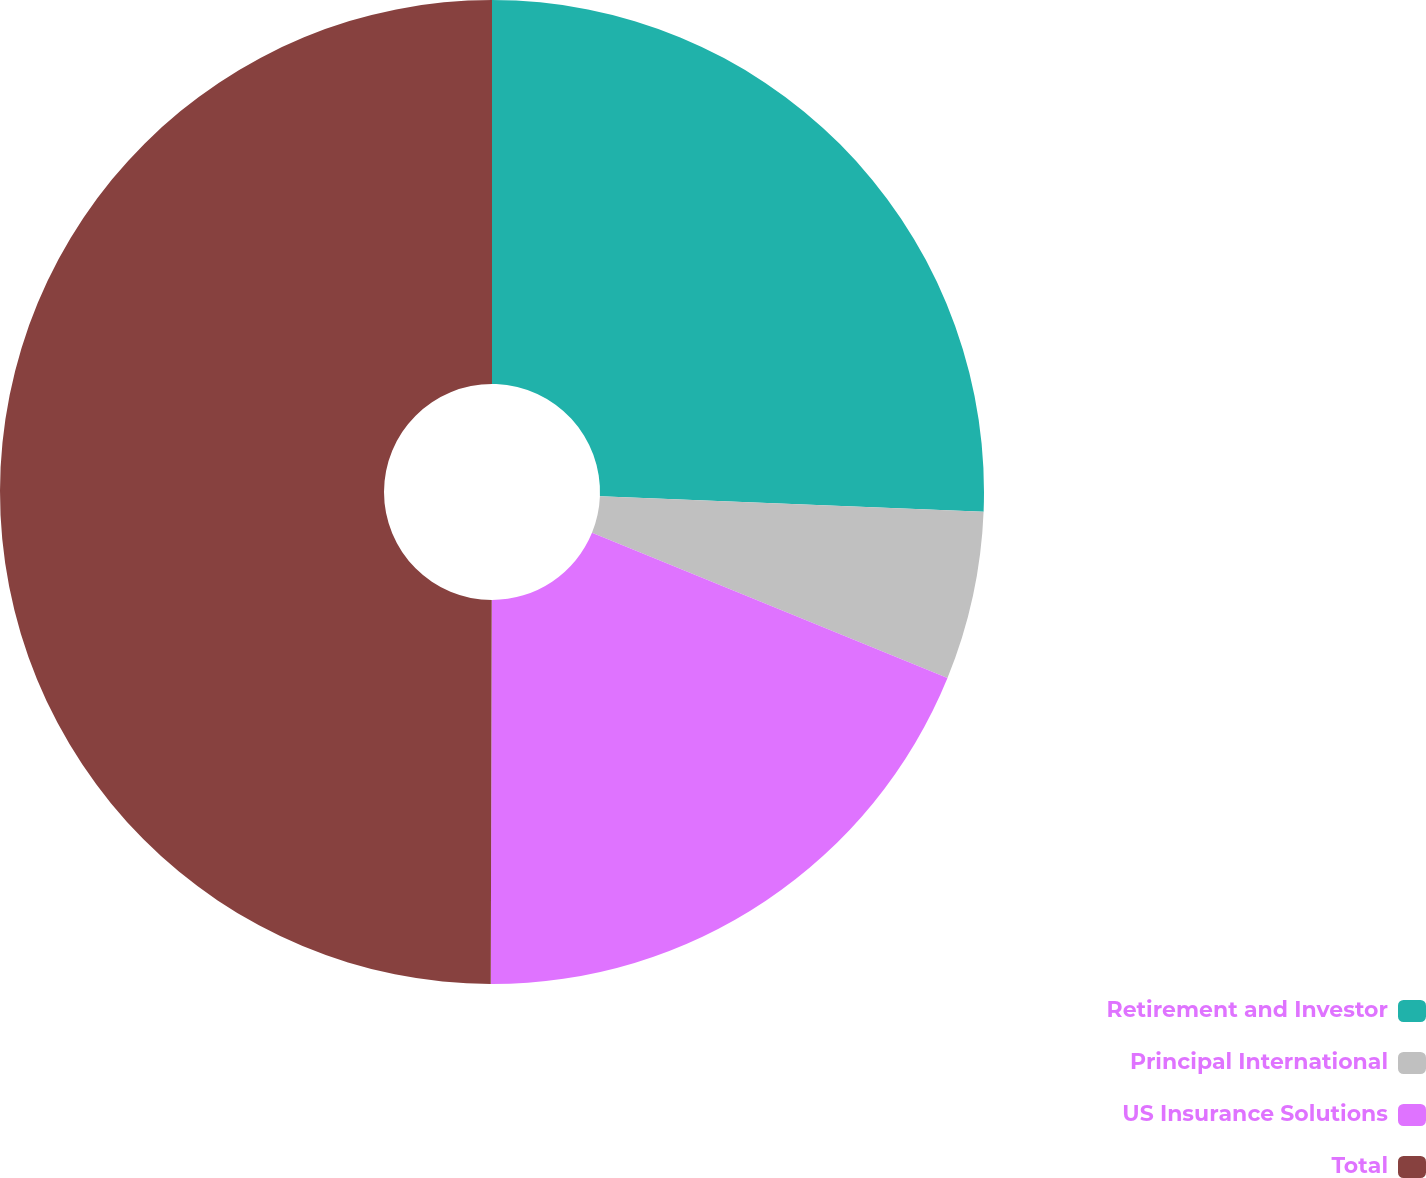Convert chart. <chart><loc_0><loc_0><loc_500><loc_500><pie_chart><fcel>Retirement and Investor<fcel>Principal International<fcel>US Insurance Solutions<fcel>Total<nl><fcel>25.64%<fcel>5.53%<fcel>18.87%<fcel>49.96%<nl></chart> 